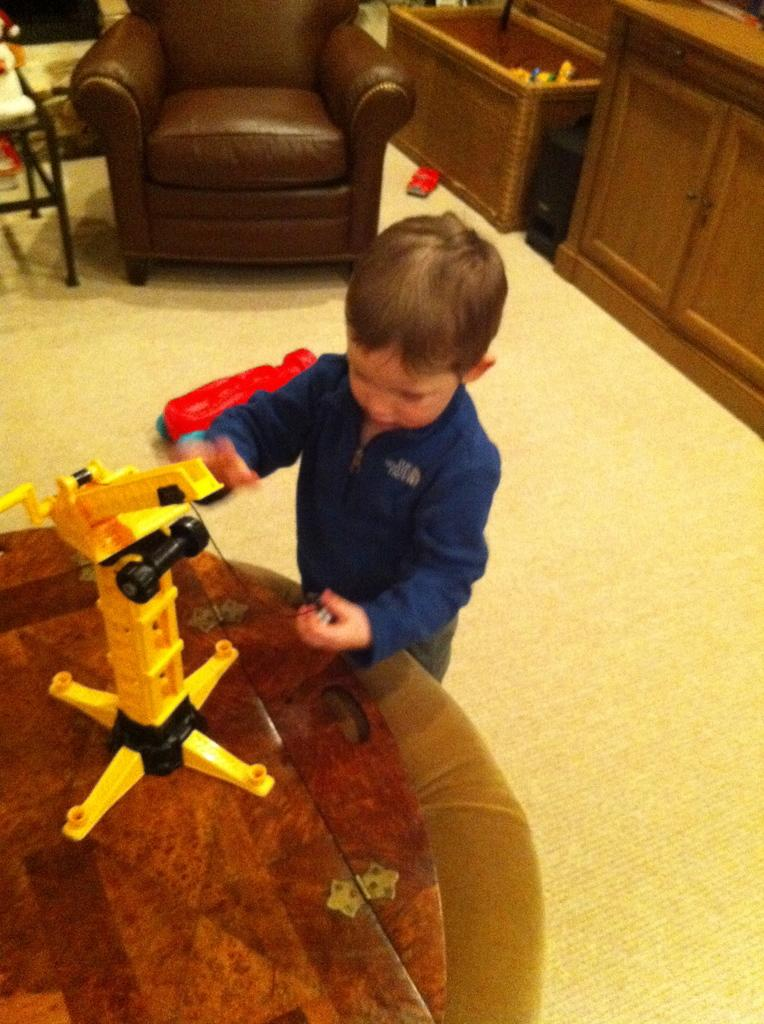Who is the main subject in the image? There is a boy in the image. What is the boy doing in the image? The boy is playing with a toy. Where is the toy located in the image? The toy is on a table. What type of throne does the beggar sit on in the image? There is no throne or beggar present in the image; it features a boy playing with a toy. 